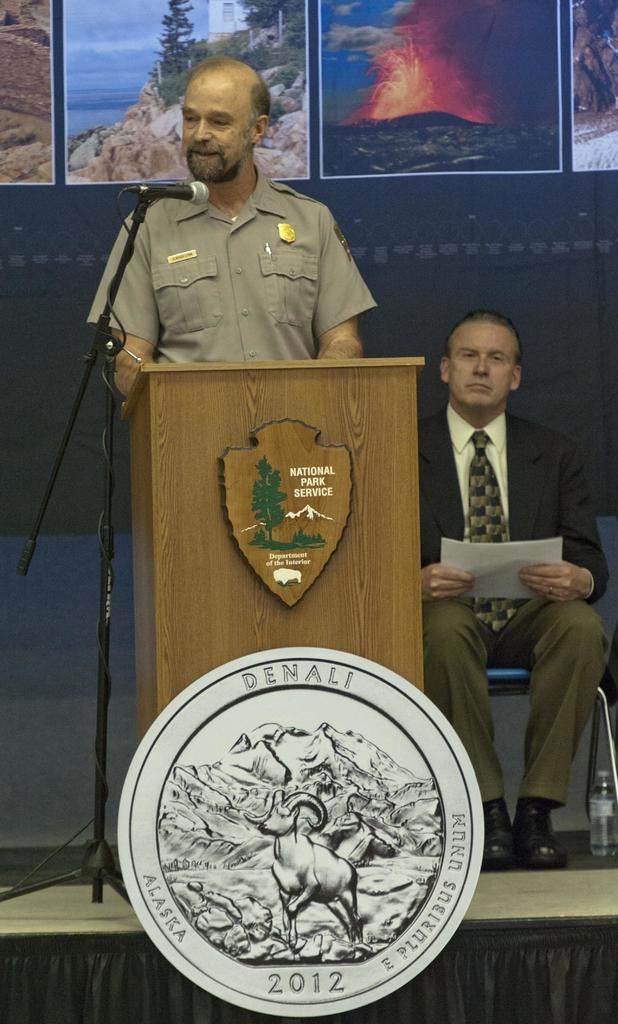<image>
Create a compact narrative representing the image presented. National park service is holding a press conference. 